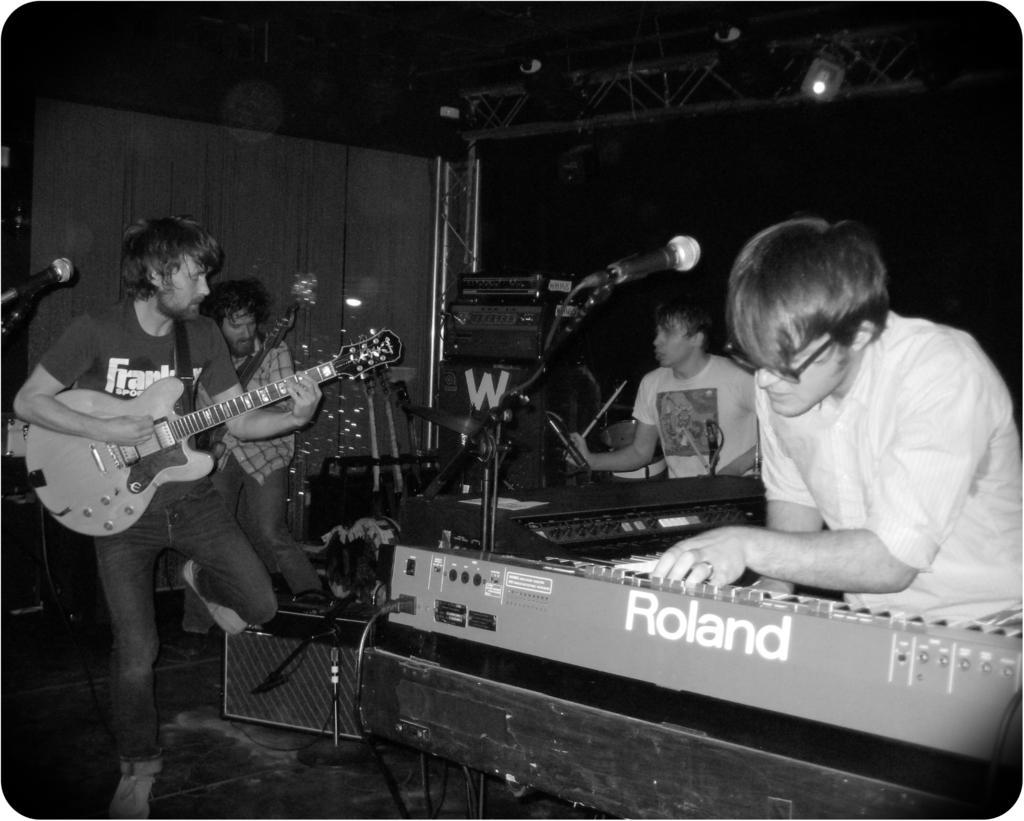Please provide a concise description of this image. In a room so many people playing musical instruments and there is a microphone on stand. 